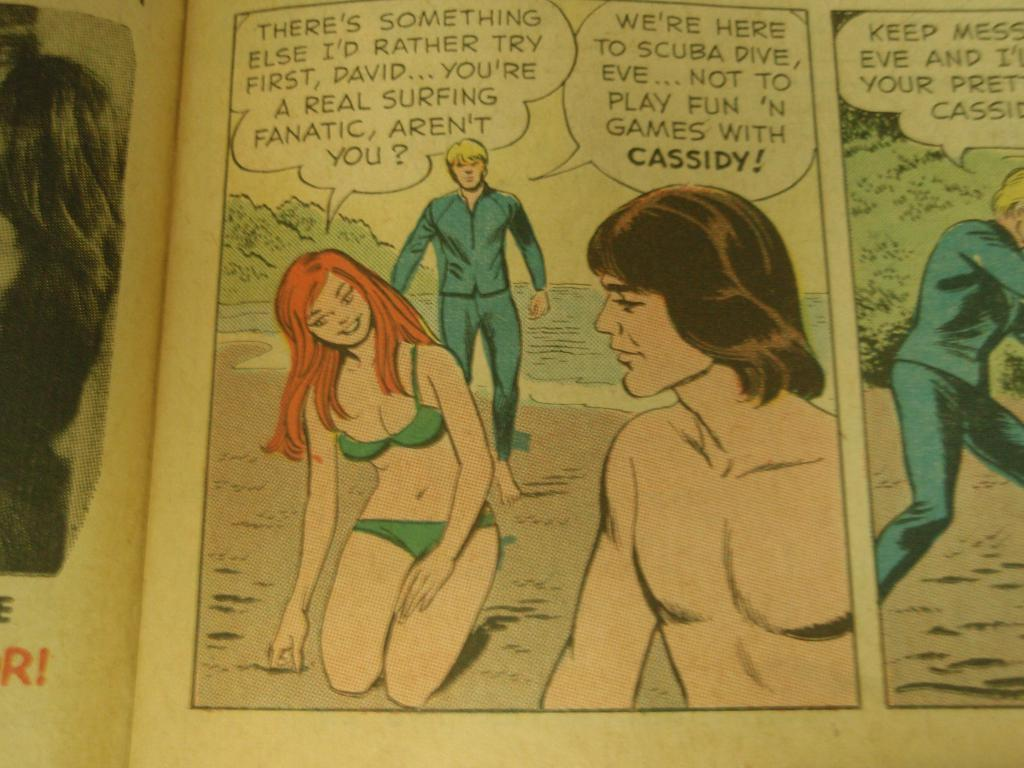<image>
Create a compact narrative representing the image presented. An old comic shows three characters Cassidy, David and Eve on a beach 